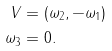Convert formula to latex. <formula><loc_0><loc_0><loc_500><loc_500>V & = ( \omega _ { 2 } , - \omega _ { 1 } ) \\ \omega _ { 3 } & = 0 .</formula> 